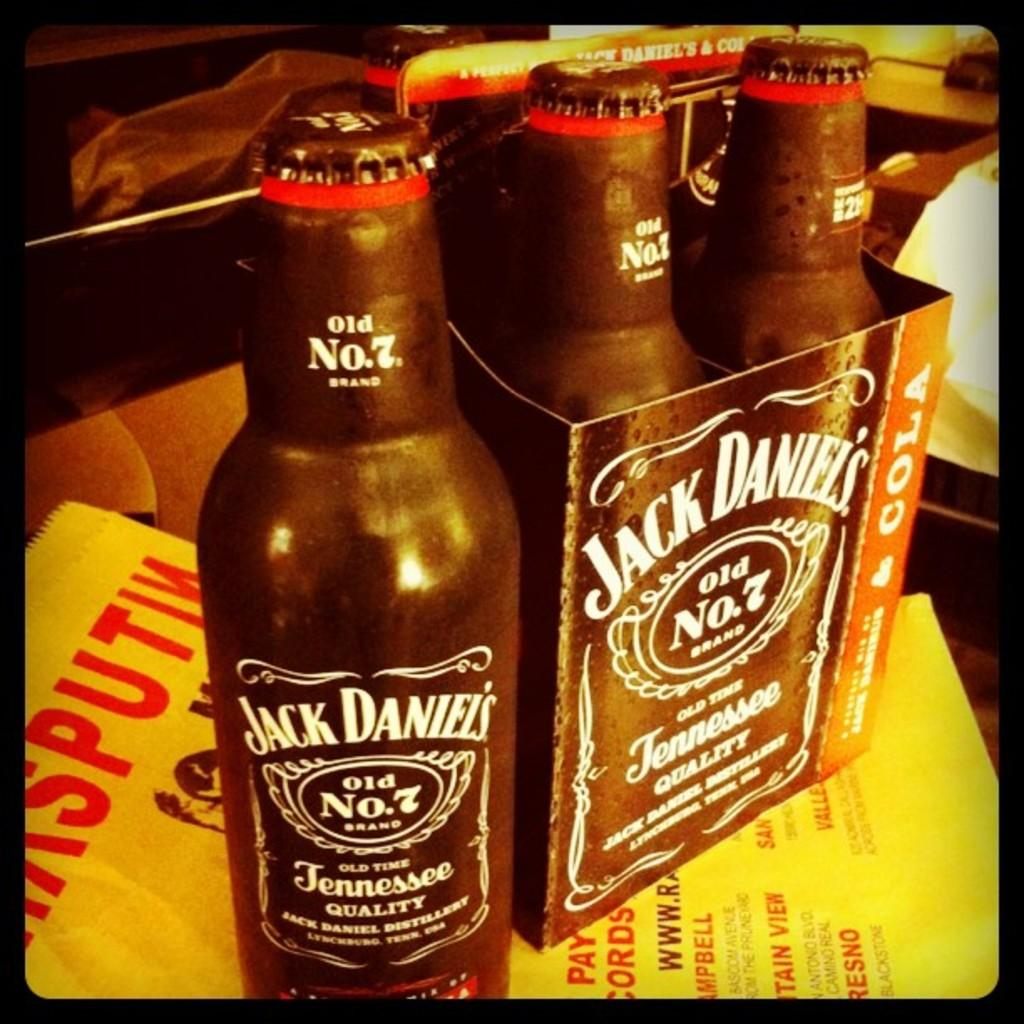<image>
Describe the image concisely. A pack of Jack Daniel's old number 7 sits on a table. 